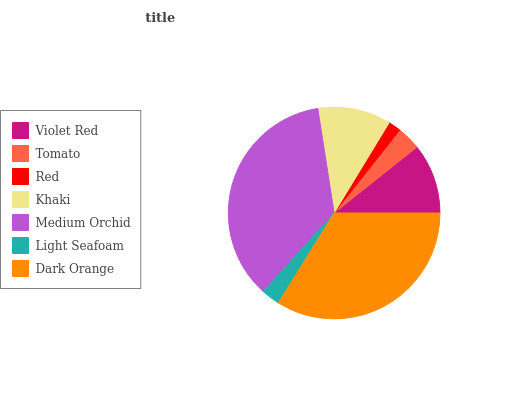Is Red the minimum?
Answer yes or no. Yes. Is Medium Orchid the maximum?
Answer yes or no. Yes. Is Tomato the minimum?
Answer yes or no. No. Is Tomato the maximum?
Answer yes or no. No. Is Violet Red greater than Tomato?
Answer yes or no. Yes. Is Tomato less than Violet Red?
Answer yes or no. Yes. Is Tomato greater than Violet Red?
Answer yes or no. No. Is Violet Red less than Tomato?
Answer yes or no. No. Is Violet Red the high median?
Answer yes or no. Yes. Is Violet Red the low median?
Answer yes or no. Yes. Is Tomato the high median?
Answer yes or no. No. Is Light Seafoam the low median?
Answer yes or no. No. 